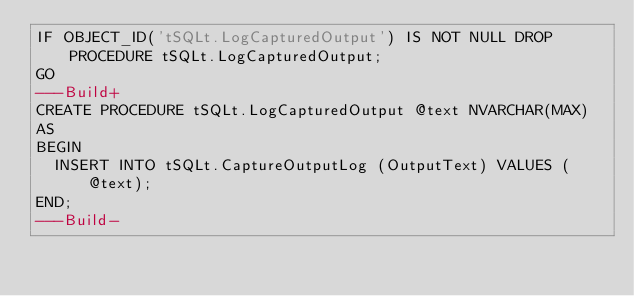<code> <loc_0><loc_0><loc_500><loc_500><_SQL_>IF OBJECT_ID('tSQLt.LogCapturedOutput') IS NOT NULL DROP PROCEDURE tSQLt.LogCapturedOutput;
GO
---Build+
CREATE PROCEDURE tSQLt.LogCapturedOutput @text NVARCHAR(MAX)
AS
BEGIN
  INSERT INTO tSQLt.CaptureOutputLog (OutputText) VALUES (@text);
END;
---Build-</code> 